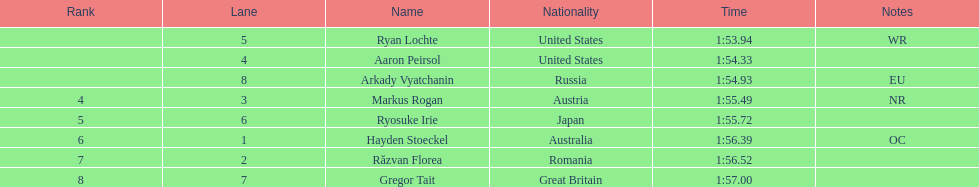What was the duration for ryosuke irie to complete? 1:55.72. 